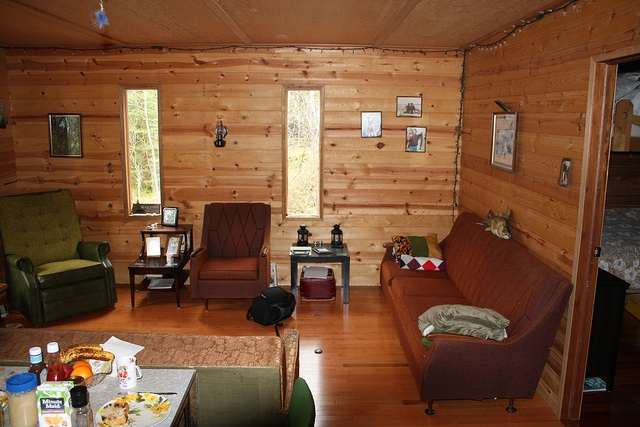Describe the objects in this image and their specific colors. I can see couch in maroon, black, and gray tones, couch in maroon, gray, and black tones, chair in maroon, black, and olive tones, couch in maroon, black, and olive tones, and chair in maroon, black, and brown tones in this image. 